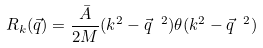<formula> <loc_0><loc_0><loc_500><loc_500>R _ { k } ( \vec { q } ) = \frac { \bar { A } } { 2 M } ( k ^ { 2 } - \vec { q } \ ^ { 2 } ) \theta ( k ^ { 2 } - \vec { q } \ ^ { 2 } )</formula> 